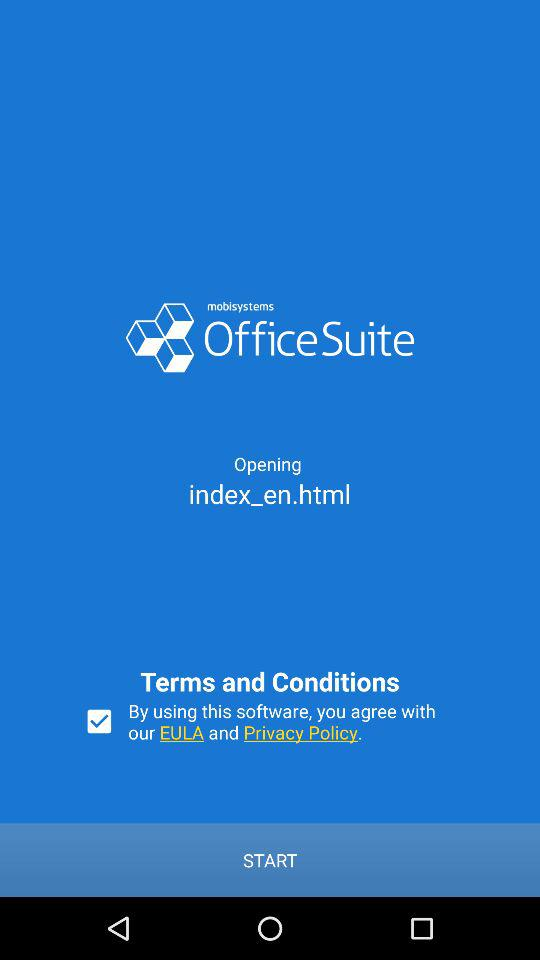What is the application name? The application name is "OfficeSuite". 